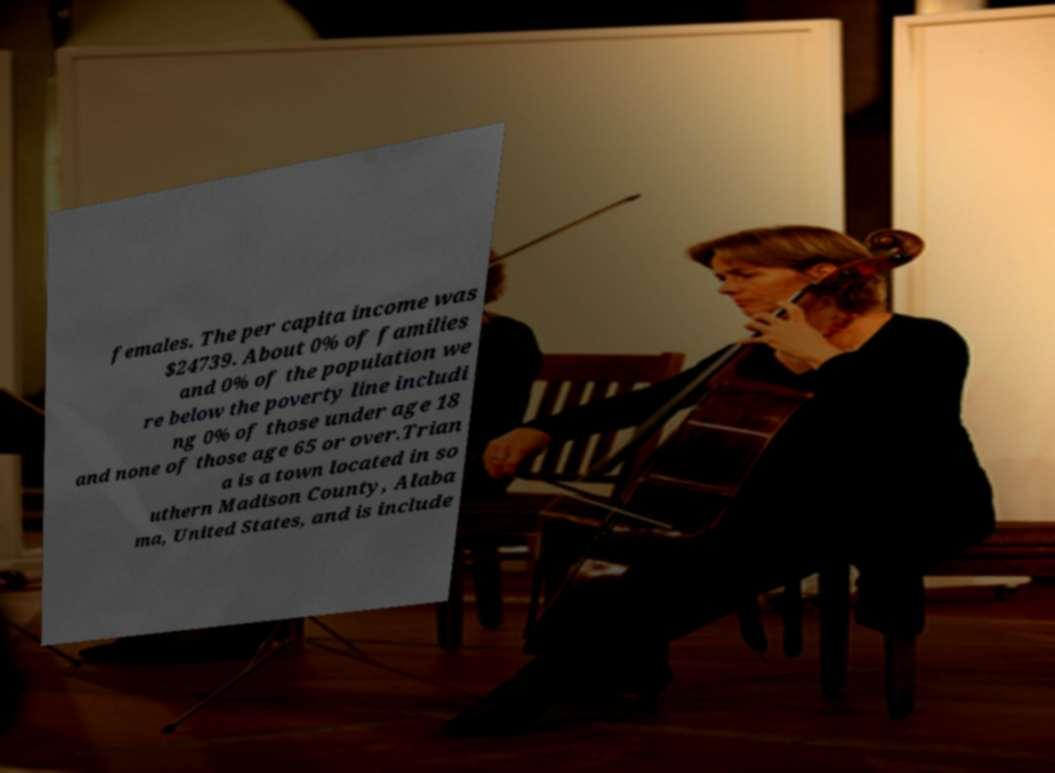Could you extract and type out the text from this image? females. The per capita income was $24739. About 0% of families and 0% of the population we re below the poverty line includi ng 0% of those under age 18 and none of those age 65 or over.Trian a is a town located in so uthern Madison County, Alaba ma, United States, and is include 